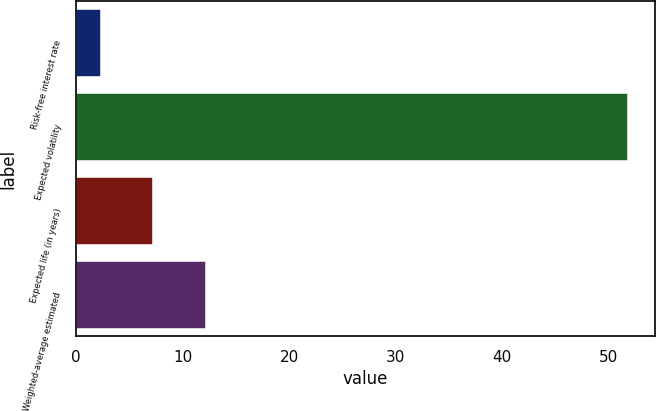<chart> <loc_0><loc_0><loc_500><loc_500><bar_chart><fcel>Risk-free interest rate<fcel>Expected volatility<fcel>Expected life (in years)<fcel>Weighted-average estimated<nl><fcel>2.18<fcel>51.75<fcel>7.14<fcel>12.1<nl></chart> 